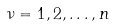Convert formula to latex. <formula><loc_0><loc_0><loc_500><loc_500>\nu = 1 , 2 , \dots , n</formula> 